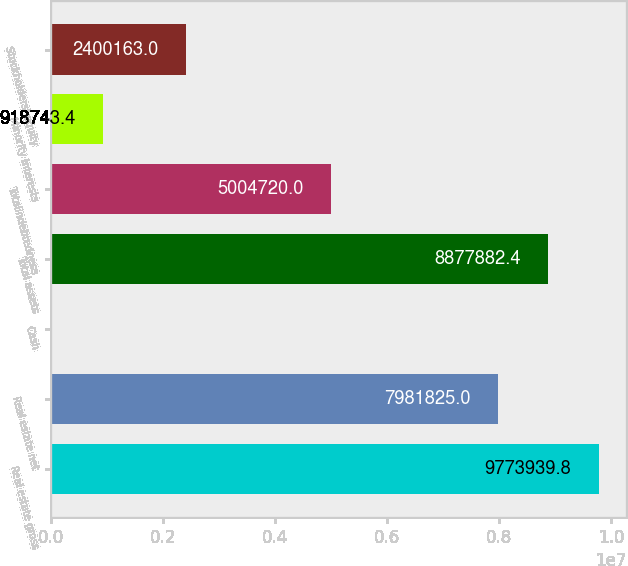Convert chart to OTSL. <chart><loc_0><loc_0><loc_500><loc_500><bar_chart><fcel>Real estate gross<fcel>Real estate net<fcel>Cash<fcel>Total assets<fcel>Totalindebtedness<fcel>Minority interests<fcel>Stockholders' equity<nl><fcel>9.77394e+06<fcel>7.98182e+06<fcel>22686<fcel>8.87788e+06<fcel>5.00472e+06<fcel>918743<fcel>2.40016e+06<nl></chart> 